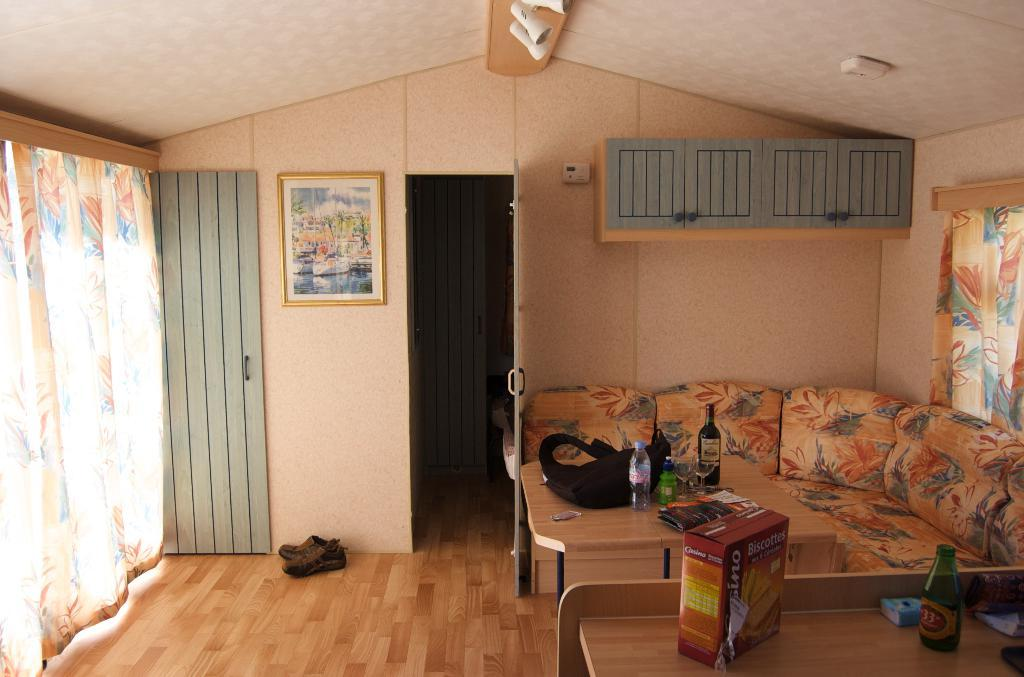What type of structure can be seen in the image? There is a wall in the image. Are there any decorative items visible in the image? Yes, there is a photo frame in the image. What is a possible entry point in the image? There is a door in the image. What type of window treatment is present in the image? There is a curtain in the image. What type of footwear can be seen in the image? There are shoes in the image. What type of lighting is present in the image? There is a light in the image. What type of seating is present in the image? There is a sofa in the image. What type of furniture is present in the image? There is a table in the image. What is on the table in the image? On the table, there is a bag, bottles, and a box. How many bears are sitting on the sofa in the image? There are no bears present in the image; it only features a sofa. What color are the toes of the person in the image? There is no person present in the image, so it is not possible to determine the color of their toes. 